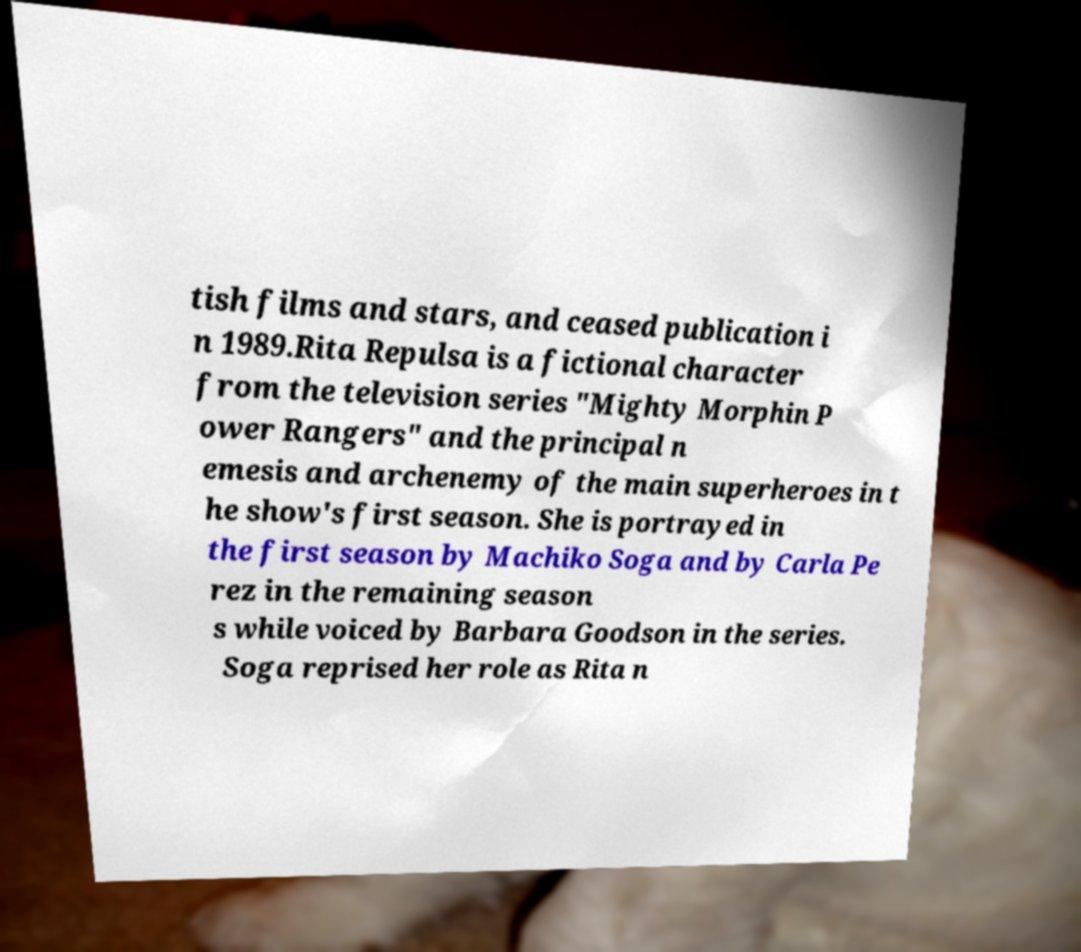What messages or text are displayed in this image? I need them in a readable, typed format. tish films and stars, and ceased publication i n 1989.Rita Repulsa is a fictional character from the television series "Mighty Morphin P ower Rangers" and the principal n emesis and archenemy of the main superheroes in t he show's first season. She is portrayed in the first season by Machiko Soga and by Carla Pe rez in the remaining season s while voiced by Barbara Goodson in the series. Soga reprised her role as Rita n 